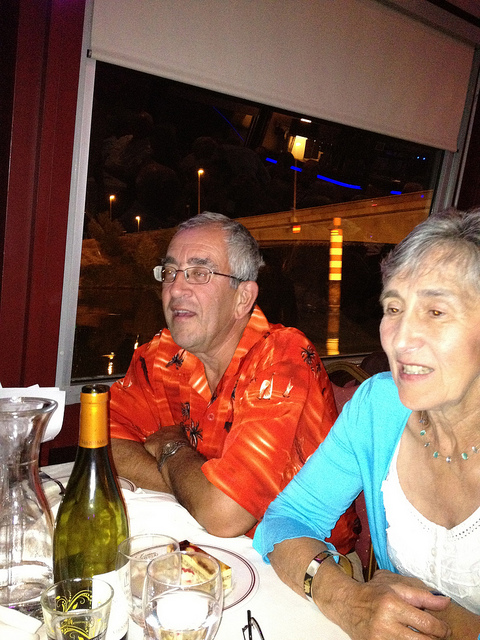Please provide the bounding box coordinate of the region this sentence describes: red shirt. The bounding box coordinates for the region describing the red shirt are approximately [0.29, 0.32, 0.66, 0.85]. 